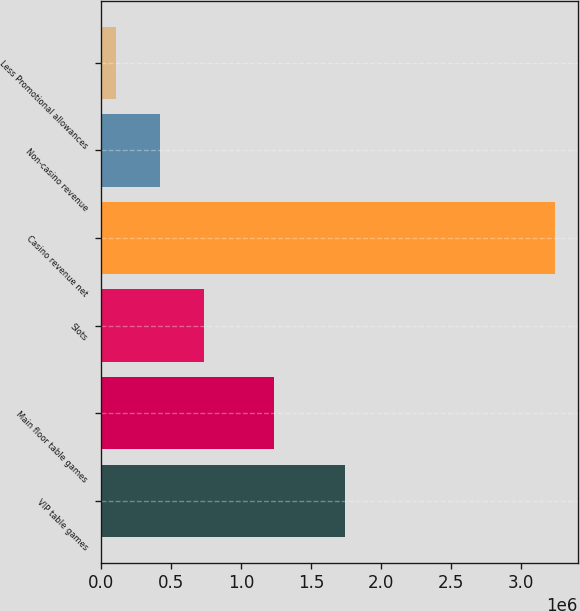Convert chart. <chart><loc_0><loc_0><loc_500><loc_500><bar_chart><fcel>VIP table games<fcel>Main floor table games<fcel>Slots<fcel>Casino revenue net<fcel>Non-casino revenue<fcel>Less Promotional allowances<nl><fcel>1.74203e+06<fcel>1.23753e+06<fcel>733873<fcel>3.24153e+06<fcel>420416<fcel>106958<nl></chart> 